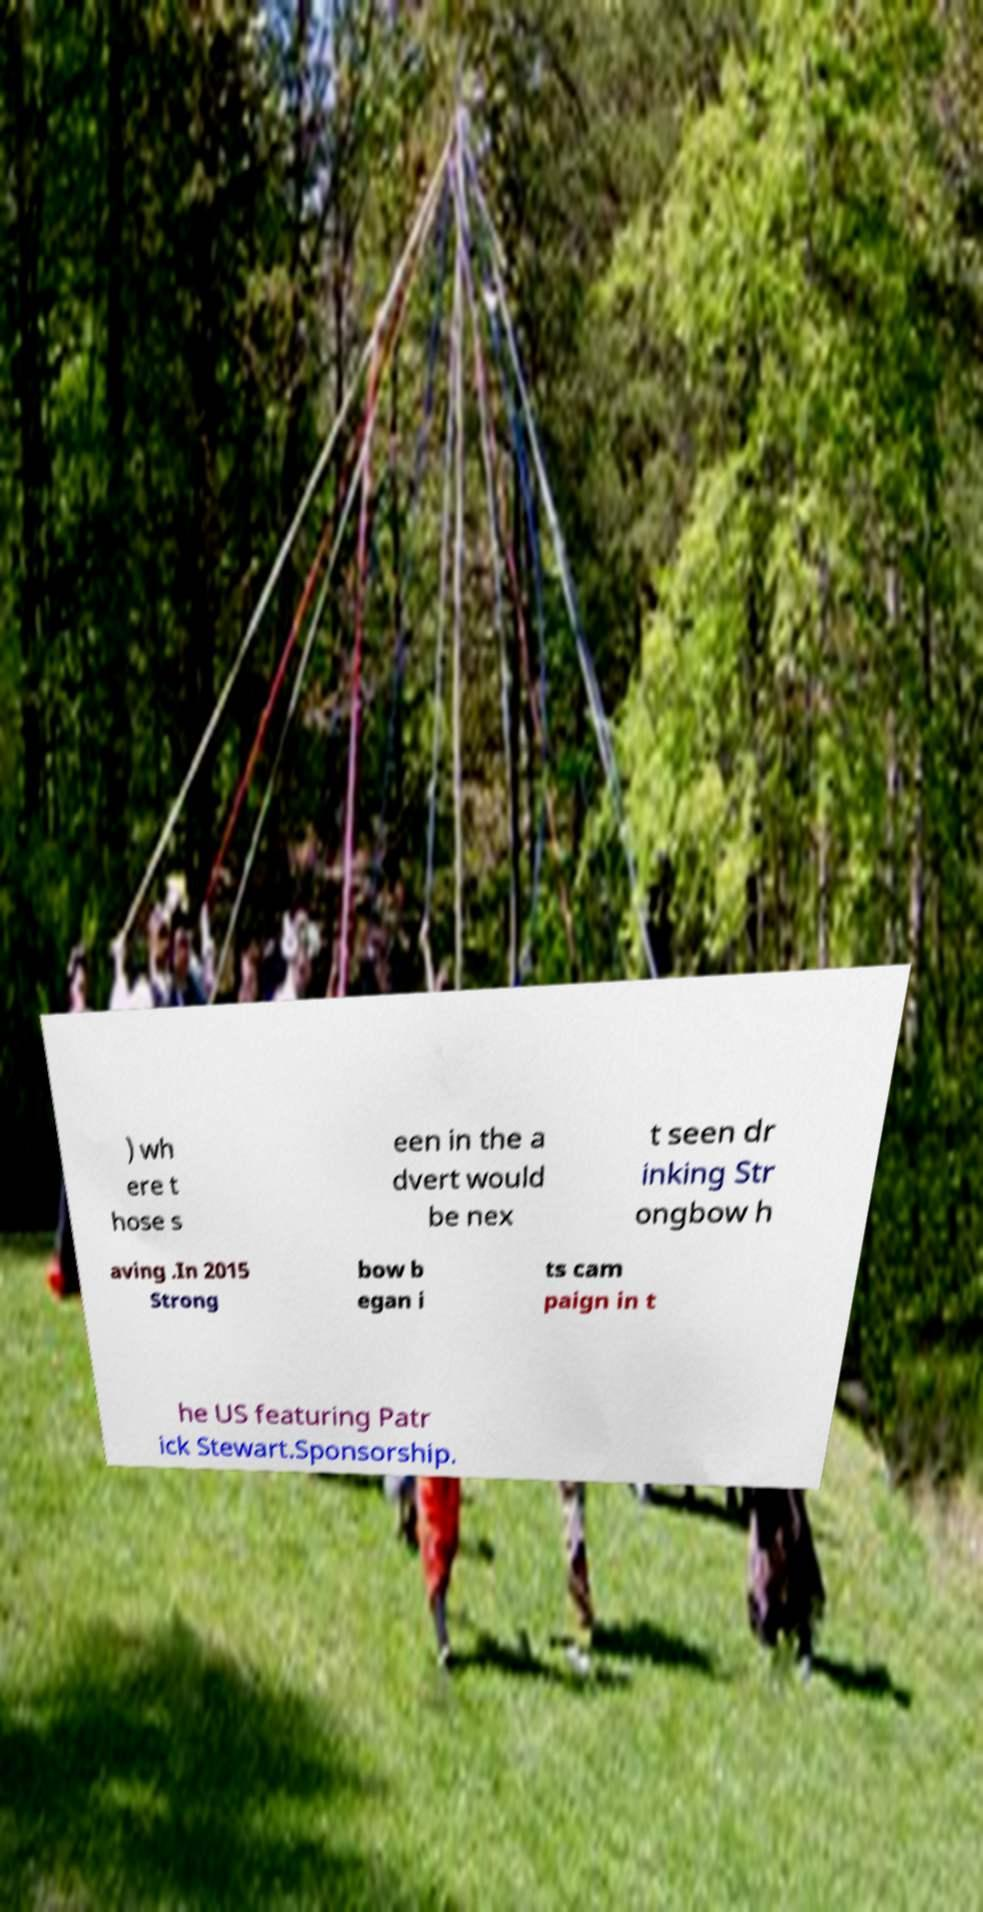Can you accurately transcribe the text from the provided image for me? ) wh ere t hose s een in the a dvert would be nex t seen dr inking Str ongbow h aving .In 2015 Strong bow b egan i ts cam paign in t he US featuring Patr ick Stewart.Sponsorship. 